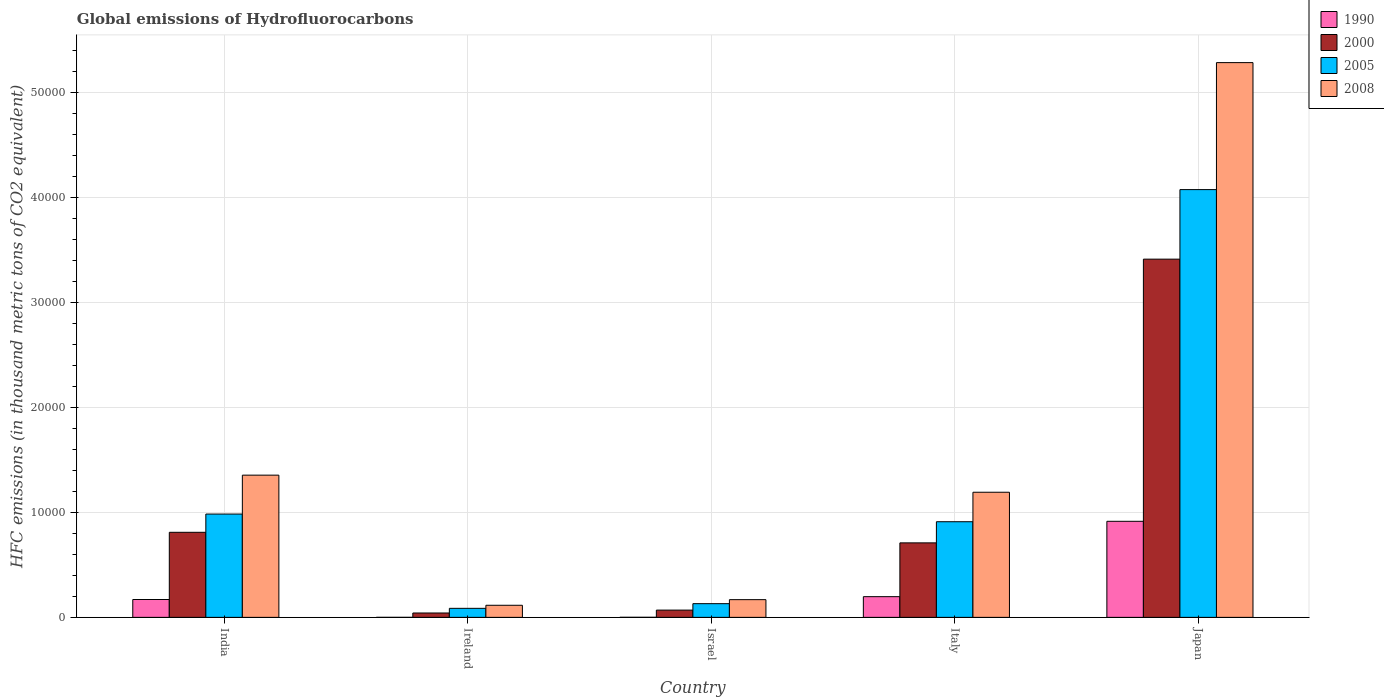Are the number of bars per tick equal to the number of legend labels?
Give a very brief answer. Yes. How many bars are there on the 4th tick from the left?
Keep it short and to the point. 4. How many bars are there on the 4th tick from the right?
Provide a succinct answer. 4. What is the label of the 5th group of bars from the left?
Offer a very short reply. Japan. In how many cases, is the number of bars for a given country not equal to the number of legend labels?
Offer a terse response. 0. What is the global emissions of Hydrofluorocarbons in 1990 in Ireland?
Offer a very short reply. 1.2. Across all countries, what is the maximum global emissions of Hydrofluorocarbons in 1990?
Provide a short and direct response. 9154.3. Across all countries, what is the minimum global emissions of Hydrofluorocarbons in 1990?
Provide a short and direct response. 1.2. In which country was the global emissions of Hydrofluorocarbons in 2008 maximum?
Provide a short and direct response. Japan. In which country was the global emissions of Hydrofluorocarbons in 1990 minimum?
Ensure brevity in your answer.  Ireland. What is the total global emissions of Hydrofluorocarbons in 2008 in the graph?
Your response must be concise. 8.12e+04. What is the difference between the global emissions of Hydrofluorocarbons in 1990 in India and that in Japan?
Your response must be concise. -7452.2. What is the difference between the global emissions of Hydrofluorocarbons in 2000 in Japan and the global emissions of Hydrofluorocarbons in 2005 in Israel?
Ensure brevity in your answer.  3.28e+04. What is the average global emissions of Hydrofluorocarbons in 2008 per country?
Make the answer very short. 1.62e+04. What is the difference between the global emissions of Hydrofluorocarbons of/in 2005 and global emissions of Hydrofluorocarbons of/in 1990 in Israel?
Give a very brief answer. 1300.4. What is the ratio of the global emissions of Hydrofluorocarbons in 2005 in India to that in Israel?
Make the answer very short. 7.54. What is the difference between the highest and the second highest global emissions of Hydrofluorocarbons in 2008?
Your answer should be very brief. 1629.2. What is the difference between the highest and the lowest global emissions of Hydrofluorocarbons in 1990?
Provide a short and direct response. 9153.1. In how many countries, is the global emissions of Hydrofluorocarbons in 2000 greater than the average global emissions of Hydrofluorocarbons in 2000 taken over all countries?
Your answer should be very brief. 1. What does the 1st bar from the left in India represents?
Ensure brevity in your answer.  1990. What does the 3rd bar from the right in Japan represents?
Keep it short and to the point. 2000. Is it the case that in every country, the sum of the global emissions of Hydrofluorocarbons in 2008 and global emissions of Hydrofluorocarbons in 1990 is greater than the global emissions of Hydrofluorocarbons in 2000?
Your answer should be very brief. Yes. How many bars are there?
Your response must be concise. 20. What is the difference between two consecutive major ticks on the Y-axis?
Keep it short and to the point. 10000. Does the graph contain grids?
Ensure brevity in your answer.  Yes. Where does the legend appear in the graph?
Offer a very short reply. Top right. How are the legend labels stacked?
Your response must be concise. Vertical. What is the title of the graph?
Offer a terse response. Global emissions of Hydrofluorocarbons. Does "2012" appear as one of the legend labels in the graph?
Your response must be concise. No. What is the label or title of the Y-axis?
Provide a short and direct response. HFC emissions (in thousand metric tons of CO2 equivalent). What is the HFC emissions (in thousand metric tons of CO2 equivalent) of 1990 in India?
Make the answer very short. 1702.1. What is the HFC emissions (in thousand metric tons of CO2 equivalent) in 2000 in India?
Your answer should be compact. 8107.2. What is the HFC emissions (in thousand metric tons of CO2 equivalent) in 2005 in India?
Keep it short and to the point. 9845.2. What is the HFC emissions (in thousand metric tons of CO2 equivalent) of 2008 in India?
Provide a succinct answer. 1.36e+04. What is the HFC emissions (in thousand metric tons of CO2 equivalent) in 1990 in Ireland?
Offer a terse response. 1.2. What is the HFC emissions (in thousand metric tons of CO2 equivalent) in 2000 in Ireland?
Your answer should be compact. 416.3. What is the HFC emissions (in thousand metric tons of CO2 equivalent) in 2005 in Ireland?
Keep it short and to the point. 859.7. What is the HFC emissions (in thousand metric tons of CO2 equivalent) of 2008 in Ireland?
Keep it short and to the point. 1152.6. What is the HFC emissions (in thousand metric tons of CO2 equivalent) of 1990 in Israel?
Provide a short and direct response. 4.6. What is the HFC emissions (in thousand metric tons of CO2 equivalent) of 2000 in Israel?
Ensure brevity in your answer.  691.9. What is the HFC emissions (in thousand metric tons of CO2 equivalent) in 2005 in Israel?
Your answer should be very brief. 1305. What is the HFC emissions (in thousand metric tons of CO2 equivalent) of 2008 in Israel?
Offer a terse response. 1687.8. What is the HFC emissions (in thousand metric tons of CO2 equivalent) of 1990 in Italy?
Keep it short and to the point. 1972.2. What is the HFC emissions (in thousand metric tons of CO2 equivalent) in 2000 in Italy?
Keep it short and to the point. 7099.5. What is the HFC emissions (in thousand metric tons of CO2 equivalent) in 2005 in Italy?
Offer a very short reply. 9114.5. What is the HFC emissions (in thousand metric tons of CO2 equivalent) in 2008 in Italy?
Provide a short and direct response. 1.19e+04. What is the HFC emissions (in thousand metric tons of CO2 equivalent) in 1990 in Japan?
Provide a short and direct response. 9154.3. What is the HFC emissions (in thousand metric tons of CO2 equivalent) of 2000 in Japan?
Provide a short and direct response. 3.41e+04. What is the HFC emissions (in thousand metric tons of CO2 equivalent) in 2005 in Japan?
Your answer should be very brief. 4.08e+04. What is the HFC emissions (in thousand metric tons of CO2 equivalent) of 2008 in Japan?
Your answer should be compact. 5.29e+04. Across all countries, what is the maximum HFC emissions (in thousand metric tons of CO2 equivalent) of 1990?
Provide a short and direct response. 9154.3. Across all countries, what is the maximum HFC emissions (in thousand metric tons of CO2 equivalent) in 2000?
Provide a succinct answer. 3.41e+04. Across all countries, what is the maximum HFC emissions (in thousand metric tons of CO2 equivalent) in 2005?
Your response must be concise. 4.08e+04. Across all countries, what is the maximum HFC emissions (in thousand metric tons of CO2 equivalent) in 2008?
Provide a succinct answer. 5.29e+04. Across all countries, what is the minimum HFC emissions (in thousand metric tons of CO2 equivalent) in 1990?
Offer a very short reply. 1.2. Across all countries, what is the minimum HFC emissions (in thousand metric tons of CO2 equivalent) of 2000?
Your response must be concise. 416.3. Across all countries, what is the minimum HFC emissions (in thousand metric tons of CO2 equivalent) in 2005?
Give a very brief answer. 859.7. Across all countries, what is the minimum HFC emissions (in thousand metric tons of CO2 equivalent) of 2008?
Ensure brevity in your answer.  1152.6. What is the total HFC emissions (in thousand metric tons of CO2 equivalent) of 1990 in the graph?
Make the answer very short. 1.28e+04. What is the total HFC emissions (in thousand metric tons of CO2 equivalent) of 2000 in the graph?
Offer a very short reply. 5.05e+04. What is the total HFC emissions (in thousand metric tons of CO2 equivalent) in 2005 in the graph?
Provide a succinct answer. 6.19e+04. What is the total HFC emissions (in thousand metric tons of CO2 equivalent) of 2008 in the graph?
Your response must be concise. 8.12e+04. What is the difference between the HFC emissions (in thousand metric tons of CO2 equivalent) in 1990 in India and that in Ireland?
Your answer should be compact. 1700.9. What is the difference between the HFC emissions (in thousand metric tons of CO2 equivalent) of 2000 in India and that in Ireland?
Give a very brief answer. 7690.9. What is the difference between the HFC emissions (in thousand metric tons of CO2 equivalent) in 2005 in India and that in Ireland?
Provide a succinct answer. 8985.5. What is the difference between the HFC emissions (in thousand metric tons of CO2 equivalent) of 2008 in India and that in Ireland?
Give a very brief answer. 1.24e+04. What is the difference between the HFC emissions (in thousand metric tons of CO2 equivalent) in 1990 in India and that in Israel?
Offer a terse response. 1697.5. What is the difference between the HFC emissions (in thousand metric tons of CO2 equivalent) of 2000 in India and that in Israel?
Your answer should be compact. 7415.3. What is the difference between the HFC emissions (in thousand metric tons of CO2 equivalent) in 2005 in India and that in Israel?
Keep it short and to the point. 8540.2. What is the difference between the HFC emissions (in thousand metric tons of CO2 equivalent) in 2008 in India and that in Israel?
Your answer should be very brief. 1.19e+04. What is the difference between the HFC emissions (in thousand metric tons of CO2 equivalent) of 1990 in India and that in Italy?
Your answer should be compact. -270.1. What is the difference between the HFC emissions (in thousand metric tons of CO2 equivalent) of 2000 in India and that in Italy?
Offer a very short reply. 1007.7. What is the difference between the HFC emissions (in thousand metric tons of CO2 equivalent) of 2005 in India and that in Italy?
Offer a very short reply. 730.7. What is the difference between the HFC emissions (in thousand metric tons of CO2 equivalent) of 2008 in India and that in Italy?
Give a very brief answer. 1629.2. What is the difference between the HFC emissions (in thousand metric tons of CO2 equivalent) in 1990 in India and that in Japan?
Give a very brief answer. -7452.2. What is the difference between the HFC emissions (in thousand metric tons of CO2 equivalent) in 2000 in India and that in Japan?
Your response must be concise. -2.60e+04. What is the difference between the HFC emissions (in thousand metric tons of CO2 equivalent) in 2005 in India and that in Japan?
Your answer should be very brief. -3.09e+04. What is the difference between the HFC emissions (in thousand metric tons of CO2 equivalent) in 2008 in India and that in Japan?
Offer a very short reply. -3.93e+04. What is the difference between the HFC emissions (in thousand metric tons of CO2 equivalent) in 2000 in Ireland and that in Israel?
Ensure brevity in your answer.  -275.6. What is the difference between the HFC emissions (in thousand metric tons of CO2 equivalent) in 2005 in Ireland and that in Israel?
Ensure brevity in your answer.  -445.3. What is the difference between the HFC emissions (in thousand metric tons of CO2 equivalent) in 2008 in Ireland and that in Israel?
Provide a succinct answer. -535.2. What is the difference between the HFC emissions (in thousand metric tons of CO2 equivalent) of 1990 in Ireland and that in Italy?
Provide a short and direct response. -1971. What is the difference between the HFC emissions (in thousand metric tons of CO2 equivalent) of 2000 in Ireland and that in Italy?
Offer a terse response. -6683.2. What is the difference between the HFC emissions (in thousand metric tons of CO2 equivalent) of 2005 in Ireland and that in Italy?
Your response must be concise. -8254.8. What is the difference between the HFC emissions (in thousand metric tons of CO2 equivalent) of 2008 in Ireland and that in Italy?
Provide a short and direct response. -1.08e+04. What is the difference between the HFC emissions (in thousand metric tons of CO2 equivalent) in 1990 in Ireland and that in Japan?
Give a very brief answer. -9153.1. What is the difference between the HFC emissions (in thousand metric tons of CO2 equivalent) of 2000 in Ireland and that in Japan?
Your answer should be very brief. -3.37e+04. What is the difference between the HFC emissions (in thousand metric tons of CO2 equivalent) of 2005 in Ireland and that in Japan?
Offer a very short reply. -3.99e+04. What is the difference between the HFC emissions (in thousand metric tons of CO2 equivalent) in 2008 in Ireland and that in Japan?
Provide a succinct answer. -5.17e+04. What is the difference between the HFC emissions (in thousand metric tons of CO2 equivalent) of 1990 in Israel and that in Italy?
Ensure brevity in your answer.  -1967.6. What is the difference between the HFC emissions (in thousand metric tons of CO2 equivalent) of 2000 in Israel and that in Italy?
Offer a very short reply. -6407.6. What is the difference between the HFC emissions (in thousand metric tons of CO2 equivalent) of 2005 in Israel and that in Italy?
Your answer should be very brief. -7809.5. What is the difference between the HFC emissions (in thousand metric tons of CO2 equivalent) of 2008 in Israel and that in Italy?
Your answer should be very brief. -1.02e+04. What is the difference between the HFC emissions (in thousand metric tons of CO2 equivalent) of 1990 in Israel and that in Japan?
Provide a short and direct response. -9149.7. What is the difference between the HFC emissions (in thousand metric tons of CO2 equivalent) of 2000 in Israel and that in Japan?
Make the answer very short. -3.34e+04. What is the difference between the HFC emissions (in thousand metric tons of CO2 equivalent) of 2005 in Israel and that in Japan?
Ensure brevity in your answer.  -3.95e+04. What is the difference between the HFC emissions (in thousand metric tons of CO2 equivalent) of 2008 in Israel and that in Japan?
Make the answer very short. -5.12e+04. What is the difference between the HFC emissions (in thousand metric tons of CO2 equivalent) of 1990 in Italy and that in Japan?
Offer a very short reply. -7182.1. What is the difference between the HFC emissions (in thousand metric tons of CO2 equivalent) in 2000 in Italy and that in Japan?
Provide a succinct answer. -2.70e+04. What is the difference between the HFC emissions (in thousand metric tons of CO2 equivalent) of 2005 in Italy and that in Japan?
Your answer should be very brief. -3.17e+04. What is the difference between the HFC emissions (in thousand metric tons of CO2 equivalent) in 2008 in Italy and that in Japan?
Make the answer very short. -4.09e+04. What is the difference between the HFC emissions (in thousand metric tons of CO2 equivalent) of 1990 in India and the HFC emissions (in thousand metric tons of CO2 equivalent) of 2000 in Ireland?
Ensure brevity in your answer.  1285.8. What is the difference between the HFC emissions (in thousand metric tons of CO2 equivalent) of 1990 in India and the HFC emissions (in thousand metric tons of CO2 equivalent) of 2005 in Ireland?
Your response must be concise. 842.4. What is the difference between the HFC emissions (in thousand metric tons of CO2 equivalent) of 1990 in India and the HFC emissions (in thousand metric tons of CO2 equivalent) of 2008 in Ireland?
Give a very brief answer. 549.5. What is the difference between the HFC emissions (in thousand metric tons of CO2 equivalent) in 2000 in India and the HFC emissions (in thousand metric tons of CO2 equivalent) in 2005 in Ireland?
Make the answer very short. 7247.5. What is the difference between the HFC emissions (in thousand metric tons of CO2 equivalent) of 2000 in India and the HFC emissions (in thousand metric tons of CO2 equivalent) of 2008 in Ireland?
Offer a very short reply. 6954.6. What is the difference between the HFC emissions (in thousand metric tons of CO2 equivalent) of 2005 in India and the HFC emissions (in thousand metric tons of CO2 equivalent) of 2008 in Ireland?
Offer a very short reply. 8692.6. What is the difference between the HFC emissions (in thousand metric tons of CO2 equivalent) in 1990 in India and the HFC emissions (in thousand metric tons of CO2 equivalent) in 2000 in Israel?
Ensure brevity in your answer.  1010.2. What is the difference between the HFC emissions (in thousand metric tons of CO2 equivalent) of 1990 in India and the HFC emissions (in thousand metric tons of CO2 equivalent) of 2005 in Israel?
Offer a very short reply. 397.1. What is the difference between the HFC emissions (in thousand metric tons of CO2 equivalent) of 2000 in India and the HFC emissions (in thousand metric tons of CO2 equivalent) of 2005 in Israel?
Keep it short and to the point. 6802.2. What is the difference between the HFC emissions (in thousand metric tons of CO2 equivalent) in 2000 in India and the HFC emissions (in thousand metric tons of CO2 equivalent) in 2008 in Israel?
Offer a terse response. 6419.4. What is the difference between the HFC emissions (in thousand metric tons of CO2 equivalent) in 2005 in India and the HFC emissions (in thousand metric tons of CO2 equivalent) in 2008 in Israel?
Your answer should be very brief. 8157.4. What is the difference between the HFC emissions (in thousand metric tons of CO2 equivalent) in 1990 in India and the HFC emissions (in thousand metric tons of CO2 equivalent) in 2000 in Italy?
Give a very brief answer. -5397.4. What is the difference between the HFC emissions (in thousand metric tons of CO2 equivalent) in 1990 in India and the HFC emissions (in thousand metric tons of CO2 equivalent) in 2005 in Italy?
Keep it short and to the point. -7412.4. What is the difference between the HFC emissions (in thousand metric tons of CO2 equivalent) of 1990 in India and the HFC emissions (in thousand metric tons of CO2 equivalent) of 2008 in Italy?
Give a very brief answer. -1.02e+04. What is the difference between the HFC emissions (in thousand metric tons of CO2 equivalent) in 2000 in India and the HFC emissions (in thousand metric tons of CO2 equivalent) in 2005 in Italy?
Give a very brief answer. -1007.3. What is the difference between the HFC emissions (in thousand metric tons of CO2 equivalent) in 2000 in India and the HFC emissions (in thousand metric tons of CO2 equivalent) in 2008 in Italy?
Give a very brief answer. -3817.3. What is the difference between the HFC emissions (in thousand metric tons of CO2 equivalent) of 2005 in India and the HFC emissions (in thousand metric tons of CO2 equivalent) of 2008 in Italy?
Give a very brief answer. -2079.3. What is the difference between the HFC emissions (in thousand metric tons of CO2 equivalent) in 1990 in India and the HFC emissions (in thousand metric tons of CO2 equivalent) in 2000 in Japan?
Make the answer very short. -3.24e+04. What is the difference between the HFC emissions (in thousand metric tons of CO2 equivalent) of 1990 in India and the HFC emissions (in thousand metric tons of CO2 equivalent) of 2005 in Japan?
Provide a succinct answer. -3.91e+04. What is the difference between the HFC emissions (in thousand metric tons of CO2 equivalent) of 1990 in India and the HFC emissions (in thousand metric tons of CO2 equivalent) of 2008 in Japan?
Your response must be concise. -5.12e+04. What is the difference between the HFC emissions (in thousand metric tons of CO2 equivalent) of 2000 in India and the HFC emissions (in thousand metric tons of CO2 equivalent) of 2005 in Japan?
Keep it short and to the point. -3.27e+04. What is the difference between the HFC emissions (in thousand metric tons of CO2 equivalent) in 2000 in India and the HFC emissions (in thousand metric tons of CO2 equivalent) in 2008 in Japan?
Make the answer very short. -4.48e+04. What is the difference between the HFC emissions (in thousand metric tons of CO2 equivalent) of 2005 in India and the HFC emissions (in thousand metric tons of CO2 equivalent) of 2008 in Japan?
Provide a succinct answer. -4.30e+04. What is the difference between the HFC emissions (in thousand metric tons of CO2 equivalent) of 1990 in Ireland and the HFC emissions (in thousand metric tons of CO2 equivalent) of 2000 in Israel?
Offer a terse response. -690.7. What is the difference between the HFC emissions (in thousand metric tons of CO2 equivalent) of 1990 in Ireland and the HFC emissions (in thousand metric tons of CO2 equivalent) of 2005 in Israel?
Ensure brevity in your answer.  -1303.8. What is the difference between the HFC emissions (in thousand metric tons of CO2 equivalent) of 1990 in Ireland and the HFC emissions (in thousand metric tons of CO2 equivalent) of 2008 in Israel?
Keep it short and to the point. -1686.6. What is the difference between the HFC emissions (in thousand metric tons of CO2 equivalent) in 2000 in Ireland and the HFC emissions (in thousand metric tons of CO2 equivalent) in 2005 in Israel?
Offer a very short reply. -888.7. What is the difference between the HFC emissions (in thousand metric tons of CO2 equivalent) of 2000 in Ireland and the HFC emissions (in thousand metric tons of CO2 equivalent) of 2008 in Israel?
Provide a succinct answer. -1271.5. What is the difference between the HFC emissions (in thousand metric tons of CO2 equivalent) in 2005 in Ireland and the HFC emissions (in thousand metric tons of CO2 equivalent) in 2008 in Israel?
Your response must be concise. -828.1. What is the difference between the HFC emissions (in thousand metric tons of CO2 equivalent) in 1990 in Ireland and the HFC emissions (in thousand metric tons of CO2 equivalent) in 2000 in Italy?
Your response must be concise. -7098.3. What is the difference between the HFC emissions (in thousand metric tons of CO2 equivalent) of 1990 in Ireland and the HFC emissions (in thousand metric tons of CO2 equivalent) of 2005 in Italy?
Offer a very short reply. -9113.3. What is the difference between the HFC emissions (in thousand metric tons of CO2 equivalent) of 1990 in Ireland and the HFC emissions (in thousand metric tons of CO2 equivalent) of 2008 in Italy?
Provide a short and direct response. -1.19e+04. What is the difference between the HFC emissions (in thousand metric tons of CO2 equivalent) in 2000 in Ireland and the HFC emissions (in thousand metric tons of CO2 equivalent) in 2005 in Italy?
Give a very brief answer. -8698.2. What is the difference between the HFC emissions (in thousand metric tons of CO2 equivalent) of 2000 in Ireland and the HFC emissions (in thousand metric tons of CO2 equivalent) of 2008 in Italy?
Offer a terse response. -1.15e+04. What is the difference between the HFC emissions (in thousand metric tons of CO2 equivalent) of 2005 in Ireland and the HFC emissions (in thousand metric tons of CO2 equivalent) of 2008 in Italy?
Offer a very short reply. -1.11e+04. What is the difference between the HFC emissions (in thousand metric tons of CO2 equivalent) in 1990 in Ireland and the HFC emissions (in thousand metric tons of CO2 equivalent) in 2000 in Japan?
Offer a very short reply. -3.41e+04. What is the difference between the HFC emissions (in thousand metric tons of CO2 equivalent) in 1990 in Ireland and the HFC emissions (in thousand metric tons of CO2 equivalent) in 2005 in Japan?
Provide a short and direct response. -4.08e+04. What is the difference between the HFC emissions (in thousand metric tons of CO2 equivalent) in 1990 in Ireland and the HFC emissions (in thousand metric tons of CO2 equivalent) in 2008 in Japan?
Offer a very short reply. -5.29e+04. What is the difference between the HFC emissions (in thousand metric tons of CO2 equivalent) of 2000 in Ireland and the HFC emissions (in thousand metric tons of CO2 equivalent) of 2005 in Japan?
Provide a short and direct response. -4.04e+04. What is the difference between the HFC emissions (in thousand metric tons of CO2 equivalent) of 2000 in Ireland and the HFC emissions (in thousand metric tons of CO2 equivalent) of 2008 in Japan?
Give a very brief answer. -5.25e+04. What is the difference between the HFC emissions (in thousand metric tons of CO2 equivalent) of 2005 in Ireland and the HFC emissions (in thousand metric tons of CO2 equivalent) of 2008 in Japan?
Offer a very short reply. -5.20e+04. What is the difference between the HFC emissions (in thousand metric tons of CO2 equivalent) of 1990 in Israel and the HFC emissions (in thousand metric tons of CO2 equivalent) of 2000 in Italy?
Give a very brief answer. -7094.9. What is the difference between the HFC emissions (in thousand metric tons of CO2 equivalent) of 1990 in Israel and the HFC emissions (in thousand metric tons of CO2 equivalent) of 2005 in Italy?
Ensure brevity in your answer.  -9109.9. What is the difference between the HFC emissions (in thousand metric tons of CO2 equivalent) of 1990 in Israel and the HFC emissions (in thousand metric tons of CO2 equivalent) of 2008 in Italy?
Your answer should be compact. -1.19e+04. What is the difference between the HFC emissions (in thousand metric tons of CO2 equivalent) of 2000 in Israel and the HFC emissions (in thousand metric tons of CO2 equivalent) of 2005 in Italy?
Your answer should be very brief. -8422.6. What is the difference between the HFC emissions (in thousand metric tons of CO2 equivalent) of 2000 in Israel and the HFC emissions (in thousand metric tons of CO2 equivalent) of 2008 in Italy?
Provide a succinct answer. -1.12e+04. What is the difference between the HFC emissions (in thousand metric tons of CO2 equivalent) of 2005 in Israel and the HFC emissions (in thousand metric tons of CO2 equivalent) of 2008 in Italy?
Provide a short and direct response. -1.06e+04. What is the difference between the HFC emissions (in thousand metric tons of CO2 equivalent) in 1990 in Israel and the HFC emissions (in thousand metric tons of CO2 equivalent) in 2000 in Japan?
Give a very brief answer. -3.41e+04. What is the difference between the HFC emissions (in thousand metric tons of CO2 equivalent) of 1990 in Israel and the HFC emissions (in thousand metric tons of CO2 equivalent) of 2005 in Japan?
Give a very brief answer. -4.08e+04. What is the difference between the HFC emissions (in thousand metric tons of CO2 equivalent) in 1990 in Israel and the HFC emissions (in thousand metric tons of CO2 equivalent) in 2008 in Japan?
Provide a short and direct response. -5.29e+04. What is the difference between the HFC emissions (in thousand metric tons of CO2 equivalent) in 2000 in Israel and the HFC emissions (in thousand metric tons of CO2 equivalent) in 2005 in Japan?
Offer a terse response. -4.01e+04. What is the difference between the HFC emissions (in thousand metric tons of CO2 equivalent) of 2000 in Israel and the HFC emissions (in thousand metric tons of CO2 equivalent) of 2008 in Japan?
Provide a succinct answer. -5.22e+04. What is the difference between the HFC emissions (in thousand metric tons of CO2 equivalent) in 2005 in Israel and the HFC emissions (in thousand metric tons of CO2 equivalent) in 2008 in Japan?
Your response must be concise. -5.16e+04. What is the difference between the HFC emissions (in thousand metric tons of CO2 equivalent) of 1990 in Italy and the HFC emissions (in thousand metric tons of CO2 equivalent) of 2000 in Japan?
Provide a short and direct response. -3.22e+04. What is the difference between the HFC emissions (in thousand metric tons of CO2 equivalent) of 1990 in Italy and the HFC emissions (in thousand metric tons of CO2 equivalent) of 2005 in Japan?
Offer a terse response. -3.88e+04. What is the difference between the HFC emissions (in thousand metric tons of CO2 equivalent) in 1990 in Italy and the HFC emissions (in thousand metric tons of CO2 equivalent) in 2008 in Japan?
Offer a terse response. -5.09e+04. What is the difference between the HFC emissions (in thousand metric tons of CO2 equivalent) in 2000 in Italy and the HFC emissions (in thousand metric tons of CO2 equivalent) in 2005 in Japan?
Offer a terse response. -3.37e+04. What is the difference between the HFC emissions (in thousand metric tons of CO2 equivalent) of 2000 in Italy and the HFC emissions (in thousand metric tons of CO2 equivalent) of 2008 in Japan?
Your response must be concise. -4.58e+04. What is the difference between the HFC emissions (in thousand metric tons of CO2 equivalent) of 2005 in Italy and the HFC emissions (in thousand metric tons of CO2 equivalent) of 2008 in Japan?
Your response must be concise. -4.38e+04. What is the average HFC emissions (in thousand metric tons of CO2 equivalent) of 1990 per country?
Offer a terse response. 2566.88. What is the average HFC emissions (in thousand metric tons of CO2 equivalent) in 2000 per country?
Your answer should be compact. 1.01e+04. What is the average HFC emissions (in thousand metric tons of CO2 equivalent) of 2005 per country?
Your response must be concise. 1.24e+04. What is the average HFC emissions (in thousand metric tons of CO2 equivalent) of 2008 per country?
Provide a succinct answer. 1.62e+04. What is the difference between the HFC emissions (in thousand metric tons of CO2 equivalent) of 1990 and HFC emissions (in thousand metric tons of CO2 equivalent) of 2000 in India?
Provide a succinct answer. -6405.1. What is the difference between the HFC emissions (in thousand metric tons of CO2 equivalent) of 1990 and HFC emissions (in thousand metric tons of CO2 equivalent) of 2005 in India?
Provide a succinct answer. -8143.1. What is the difference between the HFC emissions (in thousand metric tons of CO2 equivalent) of 1990 and HFC emissions (in thousand metric tons of CO2 equivalent) of 2008 in India?
Your answer should be compact. -1.19e+04. What is the difference between the HFC emissions (in thousand metric tons of CO2 equivalent) in 2000 and HFC emissions (in thousand metric tons of CO2 equivalent) in 2005 in India?
Your response must be concise. -1738. What is the difference between the HFC emissions (in thousand metric tons of CO2 equivalent) in 2000 and HFC emissions (in thousand metric tons of CO2 equivalent) in 2008 in India?
Offer a terse response. -5446.5. What is the difference between the HFC emissions (in thousand metric tons of CO2 equivalent) of 2005 and HFC emissions (in thousand metric tons of CO2 equivalent) of 2008 in India?
Keep it short and to the point. -3708.5. What is the difference between the HFC emissions (in thousand metric tons of CO2 equivalent) of 1990 and HFC emissions (in thousand metric tons of CO2 equivalent) of 2000 in Ireland?
Provide a short and direct response. -415.1. What is the difference between the HFC emissions (in thousand metric tons of CO2 equivalent) of 1990 and HFC emissions (in thousand metric tons of CO2 equivalent) of 2005 in Ireland?
Make the answer very short. -858.5. What is the difference between the HFC emissions (in thousand metric tons of CO2 equivalent) in 1990 and HFC emissions (in thousand metric tons of CO2 equivalent) in 2008 in Ireland?
Make the answer very short. -1151.4. What is the difference between the HFC emissions (in thousand metric tons of CO2 equivalent) in 2000 and HFC emissions (in thousand metric tons of CO2 equivalent) in 2005 in Ireland?
Offer a terse response. -443.4. What is the difference between the HFC emissions (in thousand metric tons of CO2 equivalent) of 2000 and HFC emissions (in thousand metric tons of CO2 equivalent) of 2008 in Ireland?
Your response must be concise. -736.3. What is the difference between the HFC emissions (in thousand metric tons of CO2 equivalent) of 2005 and HFC emissions (in thousand metric tons of CO2 equivalent) of 2008 in Ireland?
Keep it short and to the point. -292.9. What is the difference between the HFC emissions (in thousand metric tons of CO2 equivalent) in 1990 and HFC emissions (in thousand metric tons of CO2 equivalent) in 2000 in Israel?
Offer a terse response. -687.3. What is the difference between the HFC emissions (in thousand metric tons of CO2 equivalent) of 1990 and HFC emissions (in thousand metric tons of CO2 equivalent) of 2005 in Israel?
Provide a succinct answer. -1300.4. What is the difference between the HFC emissions (in thousand metric tons of CO2 equivalent) of 1990 and HFC emissions (in thousand metric tons of CO2 equivalent) of 2008 in Israel?
Offer a terse response. -1683.2. What is the difference between the HFC emissions (in thousand metric tons of CO2 equivalent) in 2000 and HFC emissions (in thousand metric tons of CO2 equivalent) in 2005 in Israel?
Ensure brevity in your answer.  -613.1. What is the difference between the HFC emissions (in thousand metric tons of CO2 equivalent) in 2000 and HFC emissions (in thousand metric tons of CO2 equivalent) in 2008 in Israel?
Offer a terse response. -995.9. What is the difference between the HFC emissions (in thousand metric tons of CO2 equivalent) of 2005 and HFC emissions (in thousand metric tons of CO2 equivalent) of 2008 in Israel?
Make the answer very short. -382.8. What is the difference between the HFC emissions (in thousand metric tons of CO2 equivalent) of 1990 and HFC emissions (in thousand metric tons of CO2 equivalent) of 2000 in Italy?
Ensure brevity in your answer.  -5127.3. What is the difference between the HFC emissions (in thousand metric tons of CO2 equivalent) of 1990 and HFC emissions (in thousand metric tons of CO2 equivalent) of 2005 in Italy?
Give a very brief answer. -7142.3. What is the difference between the HFC emissions (in thousand metric tons of CO2 equivalent) in 1990 and HFC emissions (in thousand metric tons of CO2 equivalent) in 2008 in Italy?
Offer a terse response. -9952.3. What is the difference between the HFC emissions (in thousand metric tons of CO2 equivalent) in 2000 and HFC emissions (in thousand metric tons of CO2 equivalent) in 2005 in Italy?
Your answer should be very brief. -2015. What is the difference between the HFC emissions (in thousand metric tons of CO2 equivalent) in 2000 and HFC emissions (in thousand metric tons of CO2 equivalent) in 2008 in Italy?
Your response must be concise. -4825. What is the difference between the HFC emissions (in thousand metric tons of CO2 equivalent) in 2005 and HFC emissions (in thousand metric tons of CO2 equivalent) in 2008 in Italy?
Make the answer very short. -2810. What is the difference between the HFC emissions (in thousand metric tons of CO2 equivalent) of 1990 and HFC emissions (in thousand metric tons of CO2 equivalent) of 2000 in Japan?
Give a very brief answer. -2.50e+04. What is the difference between the HFC emissions (in thousand metric tons of CO2 equivalent) of 1990 and HFC emissions (in thousand metric tons of CO2 equivalent) of 2005 in Japan?
Ensure brevity in your answer.  -3.16e+04. What is the difference between the HFC emissions (in thousand metric tons of CO2 equivalent) of 1990 and HFC emissions (in thousand metric tons of CO2 equivalent) of 2008 in Japan?
Offer a terse response. -4.37e+04. What is the difference between the HFC emissions (in thousand metric tons of CO2 equivalent) of 2000 and HFC emissions (in thousand metric tons of CO2 equivalent) of 2005 in Japan?
Give a very brief answer. -6628.7. What is the difference between the HFC emissions (in thousand metric tons of CO2 equivalent) in 2000 and HFC emissions (in thousand metric tons of CO2 equivalent) in 2008 in Japan?
Your response must be concise. -1.87e+04. What is the difference between the HFC emissions (in thousand metric tons of CO2 equivalent) in 2005 and HFC emissions (in thousand metric tons of CO2 equivalent) in 2008 in Japan?
Offer a very short reply. -1.21e+04. What is the ratio of the HFC emissions (in thousand metric tons of CO2 equivalent) of 1990 in India to that in Ireland?
Offer a very short reply. 1418.42. What is the ratio of the HFC emissions (in thousand metric tons of CO2 equivalent) in 2000 in India to that in Ireland?
Your answer should be very brief. 19.47. What is the ratio of the HFC emissions (in thousand metric tons of CO2 equivalent) of 2005 in India to that in Ireland?
Make the answer very short. 11.45. What is the ratio of the HFC emissions (in thousand metric tons of CO2 equivalent) in 2008 in India to that in Ireland?
Offer a very short reply. 11.76. What is the ratio of the HFC emissions (in thousand metric tons of CO2 equivalent) of 1990 in India to that in Israel?
Make the answer very short. 370.02. What is the ratio of the HFC emissions (in thousand metric tons of CO2 equivalent) in 2000 in India to that in Israel?
Offer a very short reply. 11.72. What is the ratio of the HFC emissions (in thousand metric tons of CO2 equivalent) in 2005 in India to that in Israel?
Offer a very short reply. 7.54. What is the ratio of the HFC emissions (in thousand metric tons of CO2 equivalent) of 2008 in India to that in Israel?
Your answer should be compact. 8.03. What is the ratio of the HFC emissions (in thousand metric tons of CO2 equivalent) of 1990 in India to that in Italy?
Offer a very short reply. 0.86. What is the ratio of the HFC emissions (in thousand metric tons of CO2 equivalent) in 2000 in India to that in Italy?
Ensure brevity in your answer.  1.14. What is the ratio of the HFC emissions (in thousand metric tons of CO2 equivalent) in 2005 in India to that in Italy?
Your answer should be compact. 1.08. What is the ratio of the HFC emissions (in thousand metric tons of CO2 equivalent) of 2008 in India to that in Italy?
Offer a very short reply. 1.14. What is the ratio of the HFC emissions (in thousand metric tons of CO2 equivalent) of 1990 in India to that in Japan?
Your answer should be very brief. 0.19. What is the ratio of the HFC emissions (in thousand metric tons of CO2 equivalent) of 2000 in India to that in Japan?
Offer a terse response. 0.24. What is the ratio of the HFC emissions (in thousand metric tons of CO2 equivalent) in 2005 in India to that in Japan?
Your response must be concise. 0.24. What is the ratio of the HFC emissions (in thousand metric tons of CO2 equivalent) of 2008 in India to that in Japan?
Make the answer very short. 0.26. What is the ratio of the HFC emissions (in thousand metric tons of CO2 equivalent) of 1990 in Ireland to that in Israel?
Give a very brief answer. 0.26. What is the ratio of the HFC emissions (in thousand metric tons of CO2 equivalent) in 2000 in Ireland to that in Israel?
Give a very brief answer. 0.6. What is the ratio of the HFC emissions (in thousand metric tons of CO2 equivalent) of 2005 in Ireland to that in Israel?
Your response must be concise. 0.66. What is the ratio of the HFC emissions (in thousand metric tons of CO2 equivalent) in 2008 in Ireland to that in Israel?
Offer a terse response. 0.68. What is the ratio of the HFC emissions (in thousand metric tons of CO2 equivalent) in 1990 in Ireland to that in Italy?
Provide a succinct answer. 0. What is the ratio of the HFC emissions (in thousand metric tons of CO2 equivalent) in 2000 in Ireland to that in Italy?
Make the answer very short. 0.06. What is the ratio of the HFC emissions (in thousand metric tons of CO2 equivalent) of 2005 in Ireland to that in Italy?
Offer a very short reply. 0.09. What is the ratio of the HFC emissions (in thousand metric tons of CO2 equivalent) in 2008 in Ireland to that in Italy?
Give a very brief answer. 0.1. What is the ratio of the HFC emissions (in thousand metric tons of CO2 equivalent) of 1990 in Ireland to that in Japan?
Offer a terse response. 0. What is the ratio of the HFC emissions (in thousand metric tons of CO2 equivalent) in 2000 in Ireland to that in Japan?
Your answer should be very brief. 0.01. What is the ratio of the HFC emissions (in thousand metric tons of CO2 equivalent) of 2005 in Ireland to that in Japan?
Your answer should be very brief. 0.02. What is the ratio of the HFC emissions (in thousand metric tons of CO2 equivalent) of 2008 in Ireland to that in Japan?
Your answer should be very brief. 0.02. What is the ratio of the HFC emissions (in thousand metric tons of CO2 equivalent) of 1990 in Israel to that in Italy?
Ensure brevity in your answer.  0. What is the ratio of the HFC emissions (in thousand metric tons of CO2 equivalent) of 2000 in Israel to that in Italy?
Keep it short and to the point. 0.1. What is the ratio of the HFC emissions (in thousand metric tons of CO2 equivalent) in 2005 in Israel to that in Italy?
Your answer should be very brief. 0.14. What is the ratio of the HFC emissions (in thousand metric tons of CO2 equivalent) in 2008 in Israel to that in Italy?
Your response must be concise. 0.14. What is the ratio of the HFC emissions (in thousand metric tons of CO2 equivalent) of 1990 in Israel to that in Japan?
Give a very brief answer. 0. What is the ratio of the HFC emissions (in thousand metric tons of CO2 equivalent) of 2000 in Israel to that in Japan?
Give a very brief answer. 0.02. What is the ratio of the HFC emissions (in thousand metric tons of CO2 equivalent) in 2005 in Israel to that in Japan?
Make the answer very short. 0.03. What is the ratio of the HFC emissions (in thousand metric tons of CO2 equivalent) of 2008 in Israel to that in Japan?
Your answer should be very brief. 0.03. What is the ratio of the HFC emissions (in thousand metric tons of CO2 equivalent) in 1990 in Italy to that in Japan?
Make the answer very short. 0.22. What is the ratio of the HFC emissions (in thousand metric tons of CO2 equivalent) of 2000 in Italy to that in Japan?
Your answer should be compact. 0.21. What is the ratio of the HFC emissions (in thousand metric tons of CO2 equivalent) in 2005 in Italy to that in Japan?
Ensure brevity in your answer.  0.22. What is the ratio of the HFC emissions (in thousand metric tons of CO2 equivalent) in 2008 in Italy to that in Japan?
Your response must be concise. 0.23. What is the difference between the highest and the second highest HFC emissions (in thousand metric tons of CO2 equivalent) of 1990?
Offer a terse response. 7182.1. What is the difference between the highest and the second highest HFC emissions (in thousand metric tons of CO2 equivalent) in 2000?
Your answer should be very brief. 2.60e+04. What is the difference between the highest and the second highest HFC emissions (in thousand metric tons of CO2 equivalent) of 2005?
Give a very brief answer. 3.09e+04. What is the difference between the highest and the second highest HFC emissions (in thousand metric tons of CO2 equivalent) of 2008?
Give a very brief answer. 3.93e+04. What is the difference between the highest and the lowest HFC emissions (in thousand metric tons of CO2 equivalent) of 1990?
Make the answer very short. 9153.1. What is the difference between the highest and the lowest HFC emissions (in thousand metric tons of CO2 equivalent) of 2000?
Your answer should be very brief. 3.37e+04. What is the difference between the highest and the lowest HFC emissions (in thousand metric tons of CO2 equivalent) in 2005?
Provide a succinct answer. 3.99e+04. What is the difference between the highest and the lowest HFC emissions (in thousand metric tons of CO2 equivalent) in 2008?
Keep it short and to the point. 5.17e+04. 